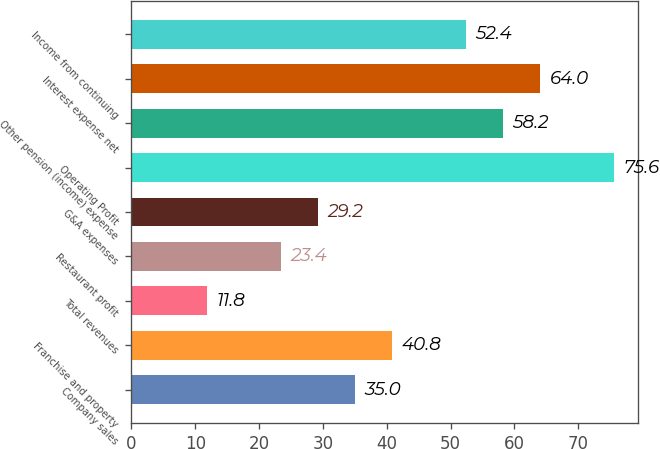Convert chart. <chart><loc_0><loc_0><loc_500><loc_500><bar_chart><fcel>Company sales<fcel>Franchise and property<fcel>Total revenues<fcel>Restaurant profit<fcel>G&A expenses<fcel>Operating Profit<fcel>Other pension (income) expense<fcel>Interest expense net<fcel>Income from continuing<nl><fcel>35<fcel>40.8<fcel>11.8<fcel>23.4<fcel>29.2<fcel>75.6<fcel>58.2<fcel>64<fcel>52.4<nl></chart> 